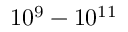Convert formula to latex. <formula><loc_0><loc_0><loc_500><loc_500>1 0 ^ { 9 } - 1 0 ^ { 1 1 }</formula> 